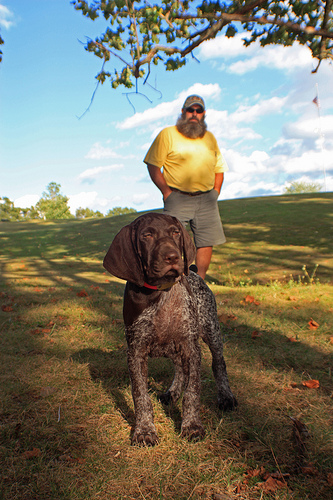What activities do you think are happening or about to happen in this scenario? It appears that the man and his dog might be enjoying a leisurely walk or about to play fetch in the open field. The dog’s attentive pose suggests it might be waiting for a command or watching something intently. 